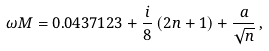<formula> <loc_0><loc_0><loc_500><loc_500>\omega M = 0 . 0 4 3 7 1 2 3 + \frac { i } { 8 } \, ( 2 n + 1 ) + \frac { a } { \sqrt { n } } \, ,</formula> 